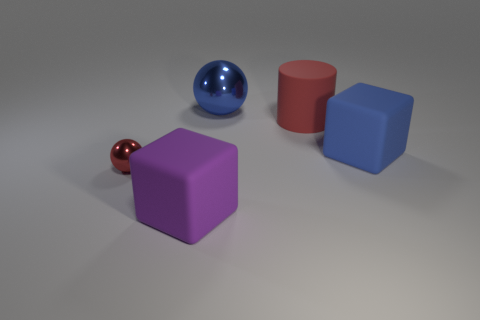The blue object that is the same material as the purple cube is what shape?
Offer a very short reply. Cube. The big cube that is to the left of the big rubber object on the right side of the big red matte cylinder is what color?
Your response must be concise. Purple. Is the big purple object the same shape as the red metal object?
Offer a very short reply. No. There is a red thing that is the same shape as the blue shiny thing; what is it made of?
Offer a very short reply. Metal. There is a big blue object that is to the right of the red thing right of the big blue metallic thing; is there a large object that is on the left side of it?
Offer a terse response. Yes. There is a blue metal object; does it have the same shape as the red thing to the right of the big blue metallic object?
Provide a succinct answer. No. Is there anything else that has the same color as the tiny ball?
Your answer should be very brief. Yes. There is a large rubber object that is in front of the large blue matte cube; is it the same color as the ball in front of the blue ball?
Your response must be concise. No. Are any green rubber cylinders visible?
Ensure brevity in your answer.  No. Are there any cylinders made of the same material as the tiny red ball?
Provide a short and direct response. No. 